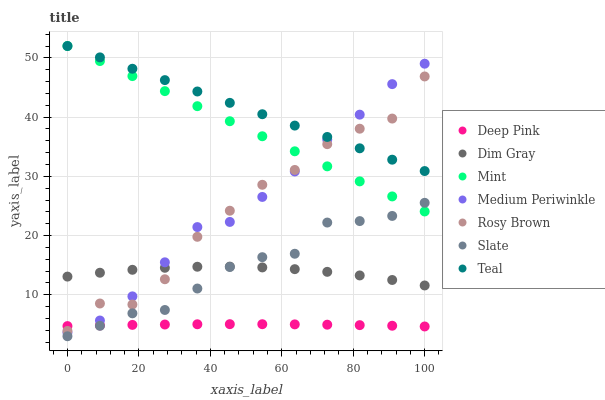Does Deep Pink have the minimum area under the curve?
Answer yes or no. Yes. Does Teal have the maximum area under the curve?
Answer yes or no. Yes. Does Slate have the minimum area under the curve?
Answer yes or no. No. Does Slate have the maximum area under the curve?
Answer yes or no. No. Is Mint the smoothest?
Answer yes or no. Yes. Is Rosy Brown the roughest?
Answer yes or no. Yes. Is Slate the smoothest?
Answer yes or no. No. Is Slate the roughest?
Answer yes or no. No. Does Slate have the lowest value?
Answer yes or no. Yes. Does Rosy Brown have the lowest value?
Answer yes or no. No. Does Mint have the highest value?
Answer yes or no. Yes. Does Slate have the highest value?
Answer yes or no. No. Is Dim Gray less than Mint?
Answer yes or no. Yes. Is Medium Periwinkle greater than Slate?
Answer yes or no. Yes. Does Dim Gray intersect Rosy Brown?
Answer yes or no. Yes. Is Dim Gray less than Rosy Brown?
Answer yes or no. No. Is Dim Gray greater than Rosy Brown?
Answer yes or no. No. Does Dim Gray intersect Mint?
Answer yes or no. No. 